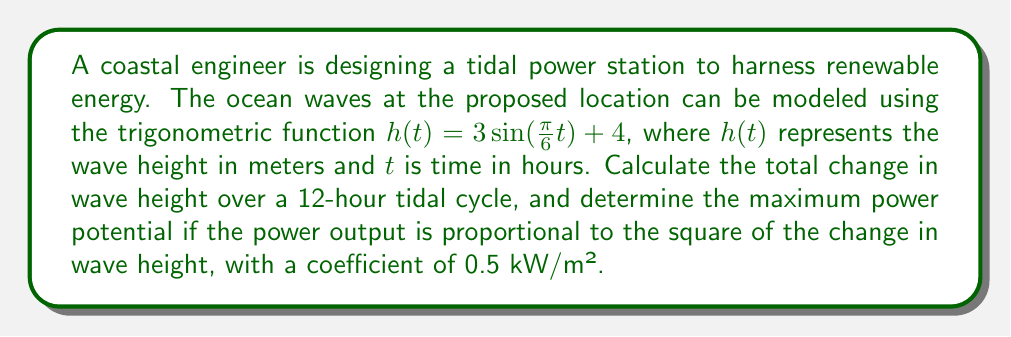Can you answer this question? To solve this problem, we'll follow these steps:

1) First, we need to find the maximum and minimum wave heights over the 12-hour cycle.

2) The wave function is $h(t) = 3\sin(\frac{\pi}{6}t) + 4$

3) The sine function oscillates between -1 and 1, so the maximum height will occur when $\sin(\frac{\pi}{6}t) = 1$, and the minimum when $\sin(\frac{\pi}{6}t) = -1$

4) Maximum height: $h_{max} = 3(1) + 4 = 7$ meters
   Minimum height: $h_{min} = 3(-1) + 4 = 1$ meter

5) The total change in wave height is the difference between the maximum and minimum:
   $\Delta h = h_{max} - h_{min} = 7 - 1 = 6$ meters

6) The power potential is proportional to the square of the change in wave height:
   $P = 0.5 (\Delta h)^2$

7) Substituting our value for $\Delta h$:
   $P = 0.5 (6)^2 = 0.5 (36) = 18$ kW/m²

Therefore, the total change in wave height over a 12-hour tidal cycle is 6 meters, and the maximum power potential is 18 kW/m².
Answer: Total change in wave height: 6 meters
Maximum power potential: 18 kW/m² 